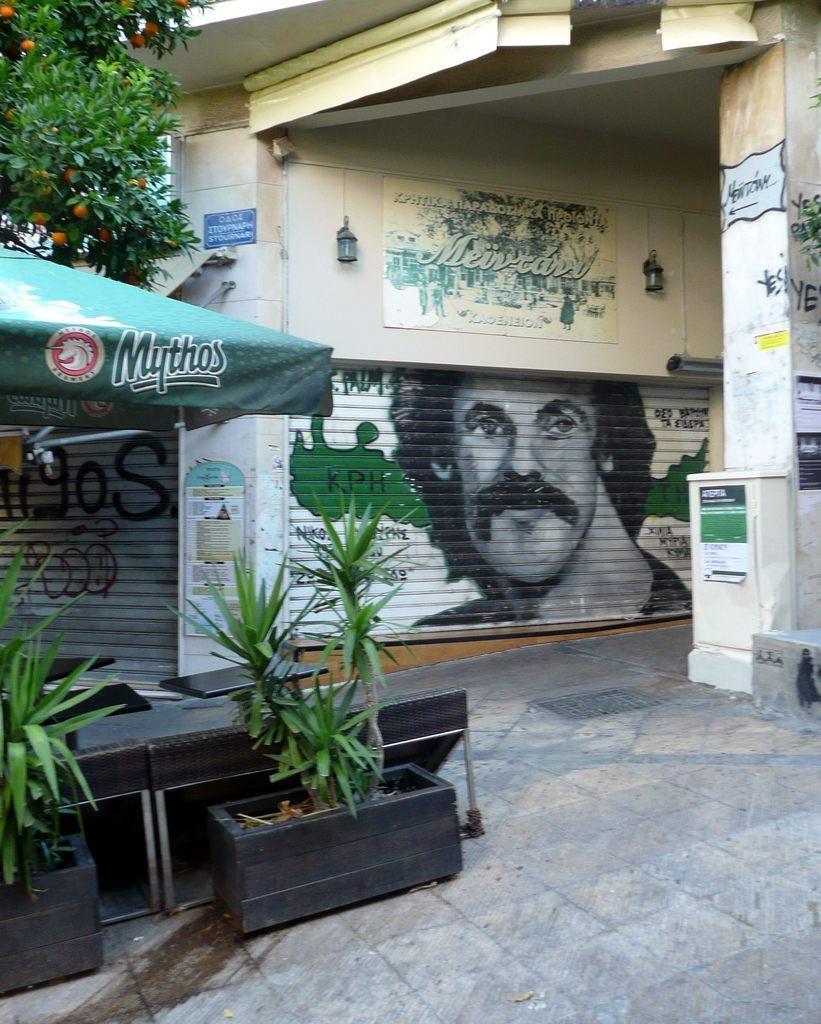Describe this image in one or two sentences. In this image I can see the building, few stores, white color box, lights, green color umbrella, plants, tables, trees and few orange color fruits to the tree, few boards and poster are attached to the wall. 